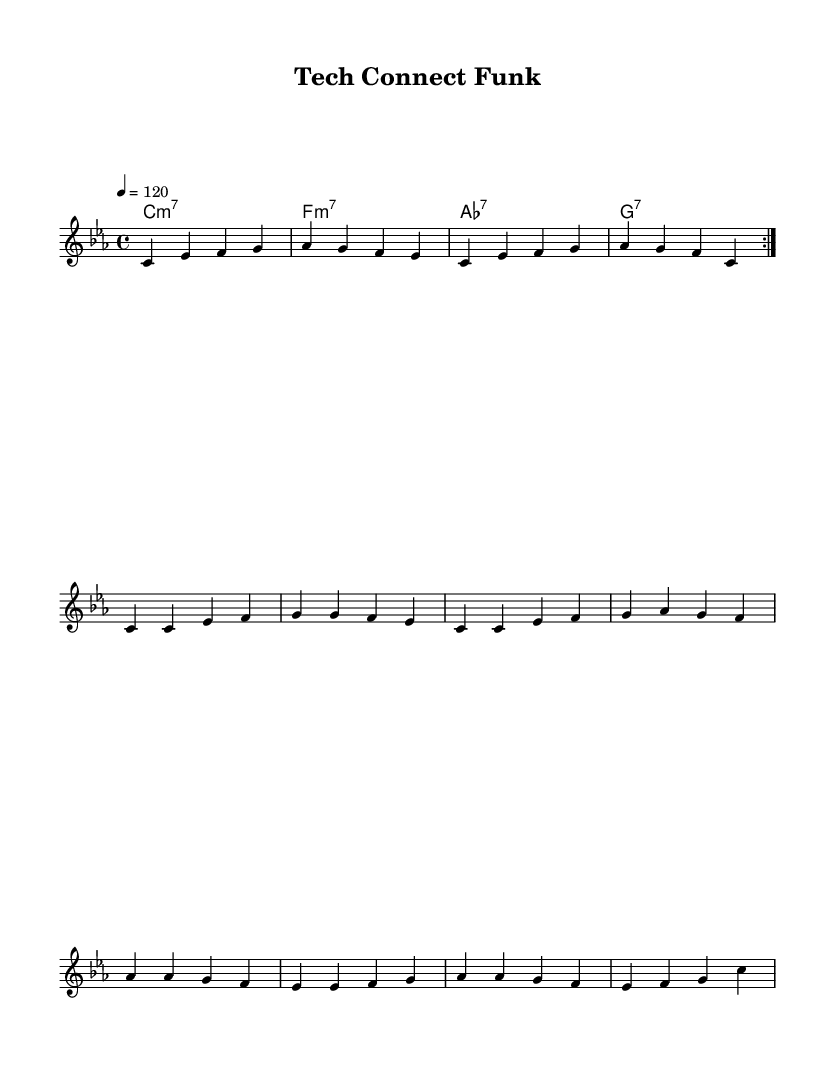What is the key signature of this music? The key signature is indicated at the beginning of the piece, showing three flats, which corresponds to C minor.
Answer: C minor What is the time signature of this piece? The time signature is found at the beginning, showing a “4/4” which means there are four beats in each measure.
Answer: 4/4 What is the tempo marking for this piece? The tempo marking is shown as “4 = 120” indicating the quarter note gets 120 beats per minute.
Answer: 120 How many measures are in the main riff section? By counting the bars in the main riff, there are four measures in total.
Answer: 4 What is the harmonic progression used in the chorus? The chords listed under harmonies show a sequence: A flat major 7, E flat major 7, A flat 7, and G 7 in the chorus.
Answer: A flat major 7, E flat major 7, A flat 7, G 7 What type of funk element is prominent in this composition? The driving rhythm and syncopation typical in funk genres, along with a catchy groove in the melody and bass, characterize the piece.
Answer: Groove What is the structure of the song based on the sections shown? The song follows a structure of main riff, verse, and chorus that repeats, showcasing a common arrangement in funk music.
Answer: Main riff, verse, chorus 